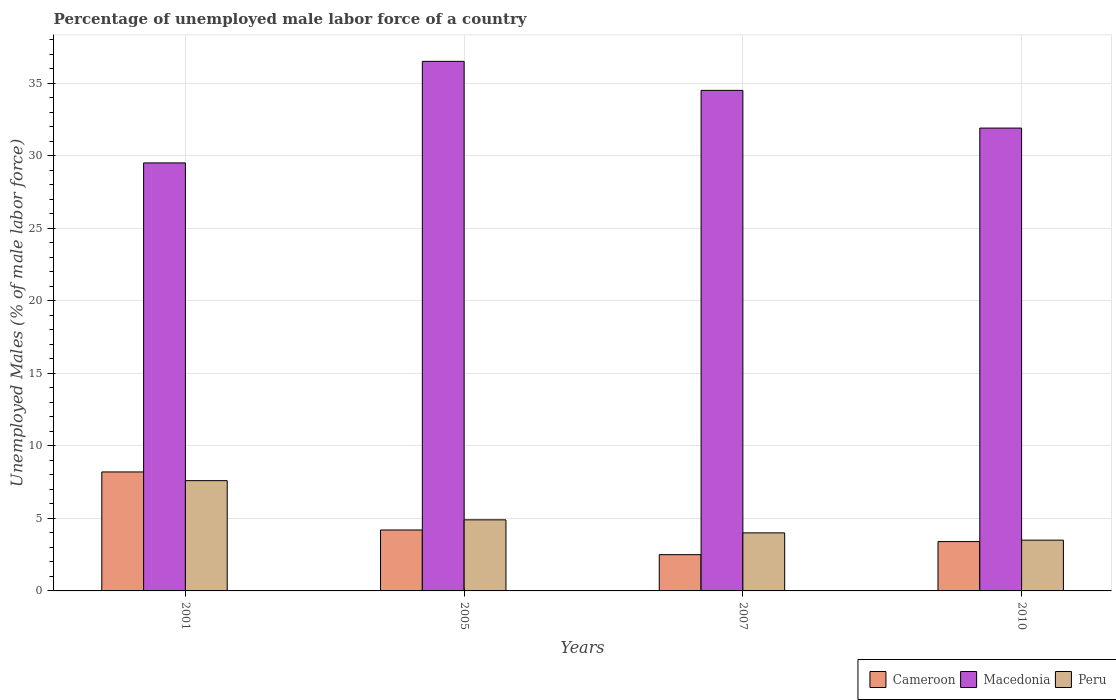How many different coloured bars are there?
Ensure brevity in your answer.  3. Are the number of bars on each tick of the X-axis equal?
Provide a short and direct response. Yes. How many bars are there on the 3rd tick from the right?
Your answer should be compact. 3. What is the percentage of unemployed male labor force in Peru in 2005?
Your answer should be compact. 4.9. Across all years, what is the maximum percentage of unemployed male labor force in Macedonia?
Make the answer very short. 36.5. Across all years, what is the minimum percentage of unemployed male labor force in Macedonia?
Keep it short and to the point. 29.5. What is the total percentage of unemployed male labor force in Macedonia in the graph?
Provide a succinct answer. 132.4. What is the difference between the percentage of unemployed male labor force in Macedonia in 2001 and that in 2005?
Your answer should be compact. -7. What is the difference between the percentage of unemployed male labor force in Macedonia in 2010 and the percentage of unemployed male labor force in Cameroon in 2001?
Offer a terse response. 23.7. What is the average percentage of unemployed male labor force in Macedonia per year?
Your answer should be very brief. 33.1. In the year 2005, what is the difference between the percentage of unemployed male labor force in Peru and percentage of unemployed male labor force in Cameroon?
Ensure brevity in your answer.  0.7. In how many years, is the percentage of unemployed male labor force in Cameroon greater than 21 %?
Offer a terse response. 0. What is the ratio of the percentage of unemployed male labor force in Peru in 2001 to that in 2007?
Provide a succinct answer. 1.9. What is the difference between the highest and the second highest percentage of unemployed male labor force in Cameroon?
Give a very brief answer. 4. What is the difference between the highest and the lowest percentage of unemployed male labor force in Macedonia?
Give a very brief answer. 7. Is the sum of the percentage of unemployed male labor force in Peru in 2001 and 2005 greater than the maximum percentage of unemployed male labor force in Cameroon across all years?
Give a very brief answer. Yes. What does the 2nd bar from the left in 2001 represents?
Provide a succinct answer. Macedonia. What does the 3rd bar from the right in 2001 represents?
Ensure brevity in your answer.  Cameroon. Is it the case that in every year, the sum of the percentage of unemployed male labor force in Peru and percentage of unemployed male labor force in Cameroon is greater than the percentage of unemployed male labor force in Macedonia?
Offer a very short reply. No. Are all the bars in the graph horizontal?
Your response must be concise. No. How many years are there in the graph?
Offer a terse response. 4. Does the graph contain grids?
Provide a short and direct response. Yes. Where does the legend appear in the graph?
Your response must be concise. Bottom right. How many legend labels are there?
Give a very brief answer. 3. What is the title of the graph?
Provide a succinct answer. Percentage of unemployed male labor force of a country. Does "San Marino" appear as one of the legend labels in the graph?
Make the answer very short. No. What is the label or title of the X-axis?
Provide a succinct answer. Years. What is the label or title of the Y-axis?
Keep it short and to the point. Unemployed Males (% of male labor force). What is the Unemployed Males (% of male labor force) in Cameroon in 2001?
Your answer should be very brief. 8.2. What is the Unemployed Males (% of male labor force) of Macedonia in 2001?
Make the answer very short. 29.5. What is the Unemployed Males (% of male labor force) of Peru in 2001?
Your response must be concise. 7.6. What is the Unemployed Males (% of male labor force) in Cameroon in 2005?
Provide a short and direct response. 4.2. What is the Unemployed Males (% of male labor force) of Macedonia in 2005?
Keep it short and to the point. 36.5. What is the Unemployed Males (% of male labor force) of Peru in 2005?
Your answer should be very brief. 4.9. What is the Unemployed Males (% of male labor force) of Cameroon in 2007?
Your answer should be very brief. 2.5. What is the Unemployed Males (% of male labor force) in Macedonia in 2007?
Provide a succinct answer. 34.5. What is the Unemployed Males (% of male labor force) in Cameroon in 2010?
Provide a short and direct response. 3.4. What is the Unemployed Males (% of male labor force) in Macedonia in 2010?
Offer a very short reply. 31.9. What is the Unemployed Males (% of male labor force) in Peru in 2010?
Your response must be concise. 3.5. Across all years, what is the maximum Unemployed Males (% of male labor force) of Cameroon?
Your response must be concise. 8.2. Across all years, what is the maximum Unemployed Males (% of male labor force) of Macedonia?
Your response must be concise. 36.5. Across all years, what is the maximum Unemployed Males (% of male labor force) in Peru?
Provide a succinct answer. 7.6. Across all years, what is the minimum Unemployed Males (% of male labor force) in Cameroon?
Your answer should be compact. 2.5. Across all years, what is the minimum Unemployed Males (% of male labor force) of Macedonia?
Ensure brevity in your answer.  29.5. Across all years, what is the minimum Unemployed Males (% of male labor force) in Peru?
Offer a very short reply. 3.5. What is the total Unemployed Males (% of male labor force) of Cameroon in the graph?
Offer a terse response. 18.3. What is the total Unemployed Males (% of male labor force) of Macedonia in the graph?
Keep it short and to the point. 132.4. What is the difference between the Unemployed Males (% of male labor force) of Cameroon in 2001 and that in 2005?
Make the answer very short. 4. What is the difference between the Unemployed Males (% of male labor force) in Macedonia in 2001 and that in 2005?
Keep it short and to the point. -7. What is the difference between the Unemployed Males (% of male labor force) of Cameroon in 2001 and that in 2007?
Give a very brief answer. 5.7. What is the difference between the Unemployed Males (% of male labor force) in Macedonia in 2001 and that in 2010?
Your answer should be compact. -2.4. What is the difference between the Unemployed Males (% of male labor force) in Peru in 2001 and that in 2010?
Provide a succinct answer. 4.1. What is the difference between the Unemployed Males (% of male labor force) in Cameroon in 2005 and that in 2007?
Make the answer very short. 1.7. What is the difference between the Unemployed Males (% of male labor force) in Cameroon in 2005 and that in 2010?
Your response must be concise. 0.8. What is the difference between the Unemployed Males (% of male labor force) in Macedonia in 2005 and that in 2010?
Give a very brief answer. 4.6. What is the difference between the Unemployed Males (% of male labor force) of Peru in 2005 and that in 2010?
Provide a succinct answer. 1.4. What is the difference between the Unemployed Males (% of male labor force) of Cameroon in 2001 and the Unemployed Males (% of male labor force) of Macedonia in 2005?
Make the answer very short. -28.3. What is the difference between the Unemployed Males (% of male labor force) of Macedonia in 2001 and the Unemployed Males (% of male labor force) of Peru in 2005?
Provide a succinct answer. 24.6. What is the difference between the Unemployed Males (% of male labor force) in Cameroon in 2001 and the Unemployed Males (% of male labor force) in Macedonia in 2007?
Give a very brief answer. -26.3. What is the difference between the Unemployed Males (% of male labor force) of Macedonia in 2001 and the Unemployed Males (% of male labor force) of Peru in 2007?
Give a very brief answer. 25.5. What is the difference between the Unemployed Males (% of male labor force) in Cameroon in 2001 and the Unemployed Males (% of male labor force) in Macedonia in 2010?
Ensure brevity in your answer.  -23.7. What is the difference between the Unemployed Males (% of male labor force) in Cameroon in 2001 and the Unemployed Males (% of male labor force) in Peru in 2010?
Your answer should be compact. 4.7. What is the difference between the Unemployed Males (% of male labor force) in Macedonia in 2001 and the Unemployed Males (% of male labor force) in Peru in 2010?
Offer a very short reply. 26. What is the difference between the Unemployed Males (% of male labor force) of Cameroon in 2005 and the Unemployed Males (% of male labor force) of Macedonia in 2007?
Keep it short and to the point. -30.3. What is the difference between the Unemployed Males (% of male labor force) of Macedonia in 2005 and the Unemployed Males (% of male labor force) of Peru in 2007?
Provide a succinct answer. 32.5. What is the difference between the Unemployed Males (% of male labor force) in Cameroon in 2005 and the Unemployed Males (% of male labor force) in Macedonia in 2010?
Offer a very short reply. -27.7. What is the difference between the Unemployed Males (% of male labor force) in Cameroon in 2005 and the Unemployed Males (% of male labor force) in Peru in 2010?
Ensure brevity in your answer.  0.7. What is the difference between the Unemployed Males (% of male labor force) in Cameroon in 2007 and the Unemployed Males (% of male labor force) in Macedonia in 2010?
Give a very brief answer. -29.4. What is the average Unemployed Males (% of male labor force) of Cameroon per year?
Ensure brevity in your answer.  4.58. What is the average Unemployed Males (% of male labor force) in Macedonia per year?
Your answer should be compact. 33.1. In the year 2001, what is the difference between the Unemployed Males (% of male labor force) of Cameroon and Unemployed Males (% of male labor force) of Macedonia?
Ensure brevity in your answer.  -21.3. In the year 2001, what is the difference between the Unemployed Males (% of male labor force) in Cameroon and Unemployed Males (% of male labor force) in Peru?
Offer a terse response. 0.6. In the year 2001, what is the difference between the Unemployed Males (% of male labor force) of Macedonia and Unemployed Males (% of male labor force) of Peru?
Your answer should be very brief. 21.9. In the year 2005, what is the difference between the Unemployed Males (% of male labor force) in Cameroon and Unemployed Males (% of male labor force) in Macedonia?
Give a very brief answer. -32.3. In the year 2005, what is the difference between the Unemployed Males (% of male labor force) in Cameroon and Unemployed Males (% of male labor force) in Peru?
Offer a very short reply. -0.7. In the year 2005, what is the difference between the Unemployed Males (% of male labor force) in Macedonia and Unemployed Males (% of male labor force) in Peru?
Keep it short and to the point. 31.6. In the year 2007, what is the difference between the Unemployed Males (% of male labor force) of Cameroon and Unemployed Males (% of male labor force) of Macedonia?
Make the answer very short. -32. In the year 2007, what is the difference between the Unemployed Males (% of male labor force) of Cameroon and Unemployed Males (% of male labor force) of Peru?
Keep it short and to the point. -1.5. In the year 2007, what is the difference between the Unemployed Males (% of male labor force) in Macedonia and Unemployed Males (% of male labor force) in Peru?
Make the answer very short. 30.5. In the year 2010, what is the difference between the Unemployed Males (% of male labor force) of Cameroon and Unemployed Males (% of male labor force) of Macedonia?
Make the answer very short. -28.5. In the year 2010, what is the difference between the Unemployed Males (% of male labor force) of Macedonia and Unemployed Males (% of male labor force) of Peru?
Make the answer very short. 28.4. What is the ratio of the Unemployed Males (% of male labor force) of Cameroon in 2001 to that in 2005?
Your response must be concise. 1.95. What is the ratio of the Unemployed Males (% of male labor force) in Macedonia in 2001 to that in 2005?
Offer a terse response. 0.81. What is the ratio of the Unemployed Males (% of male labor force) of Peru in 2001 to that in 2005?
Your answer should be very brief. 1.55. What is the ratio of the Unemployed Males (% of male labor force) in Cameroon in 2001 to that in 2007?
Give a very brief answer. 3.28. What is the ratio of the Unemployed Males (% of male labor force) in Macedonia in 2001 to that in 2007?
Your answer should be compact. 0.86. What is the ratio of the Unemployed Males (% of male labor force) of Peru in 2001 to that in 2007?
Offer a very short reply. 1.9. What is the ratio of the Unemployed Males (% of male labor force) in Cameroon in 2001 to that in 2010?
Make the answer very short. 2.41. What is the ratio of the Unemployed Males (% of male labor force) in Macedonia in 2001 to that in 2010?
Your answer should be compact. 0.92. What is the ratio of the Unemployed Males (% of male labor force) of Peru in 2001 to that in 2010?
Offer a terse response. 2.17. What is the ratio of the Unemployed Males (% of male labor force) in Cameroon in 2005 to that in 2007?
Your response must be concise. 1.68. What is the ratio of the Unemployed Males (% of male labor force) in Macedonia in 2005 to that in 2007?
Give a very brief answer. 1.06. What is the ratio of the Unemployed Males (% of male labor force) of Peru in 2005 to that in 2007?
Offer a very short reply. 1.23. What is the ratio of the Unemployed Males (% of male labor force) of Cameroon in 2005 to that in 2010?
Make the answer very short. 1.24. What is the ratio of the Unemployed Males (% of male labor force) in Macedonia in 2005 to that in 2010?
Ensure brevity in your answer.  1.14. What is the ratio of the Unemployed Males (% of male labor force) in Peru in 2005 to that in 2010?
Make the answer very short. 1.4. What is the ratio of the Unemployed Males (% of male labor force) in Cameroon in 2007 to that in 2010?
Your answer should be compact. 0.74. What is the ratio of the Unemployed Males (% of male labor force) of Macedonia in 2007 to that in 2010?
Keep it short and to the point. 1.08. What is the difference between the highest and the lowest Unemployed Males (% of male labor force) in Peru?
Your answer should be very brief. 4.1. 